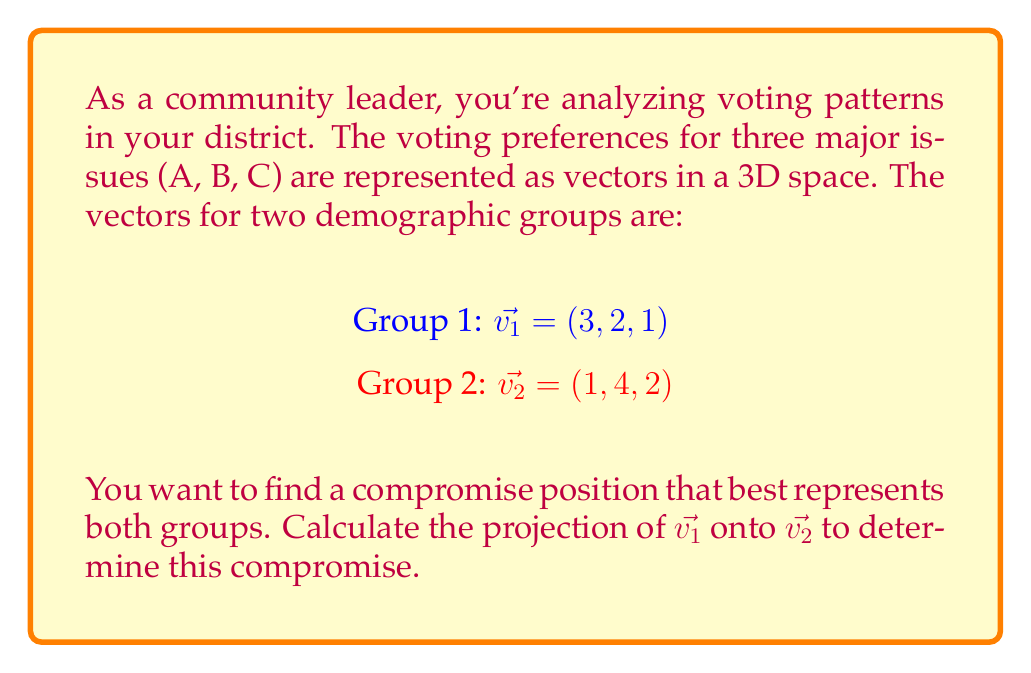Can you solve this math problem? To find the projection of $\vec{v_1}$ onto $\vec{v_2}$, we'll use the formula:

$$\text{proj}_{\vec{v_2}}\vec{v_1} = \frac{\vec{v_1} \cdot \vec{v_2}}{\|\vec{v_2}\|^2} \vec{v_2}$$

Step 1: Calculate the dot product $\vec{v_1} \cdot \vec{v_2}$
$\vec{v_1} \cdot \vec{v_2} = (3)(1) + (2)(4) + (1)(2) = 3 + 8 + 2 = 13$

Step 2: Calculate $\|\vec{v_2}\|^2$
$\|\vec{v_2}\|^2 = 1^2 + 4^2 + 2^2 = 1 + 16 + 4 = 21$

Step 3: Calculate the scalar projection
$\frac{\vec{v_1} \cdot \vec{v_2}}{\|\vec{v_2}\|^2} = \frac{13}{21}$

Step 4: Multiply the result by $\vec{v_2}$
$\text{proj}_{\vec{v_2}}\vec{v_1} = \frac{13}{21} (1, 4, 2) = (\frac{13}{21}, \frac{52}{21}, \frac{26}{21})$

This vector represents the compromise position that best aligns with both groups' preferences, weighted towards Group 2's priorities.
Answer: $(\frac{13}{21}, \frac{52}{21}, \frac{26}{21})$ 